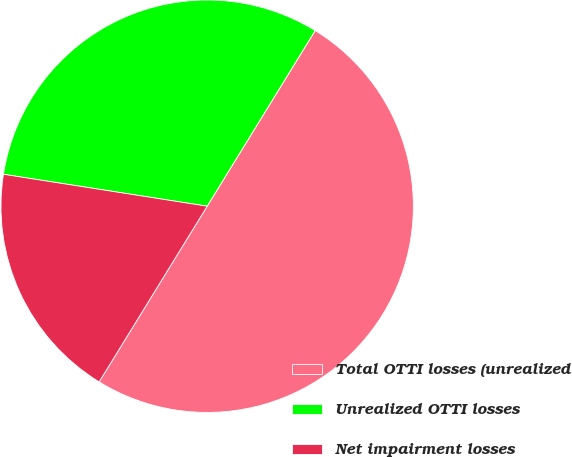Convert chart. <chart><loc_0><loc_0><loc_500><loc_500><pie_chart><fcel>Total OTTI losses (unrealized<fcel>Unrealized OTTI losses<fcel>Net impairment losses<nl><fcel>50.0%<fcel>31.3%<fcel>18.7%<nl></chart> 